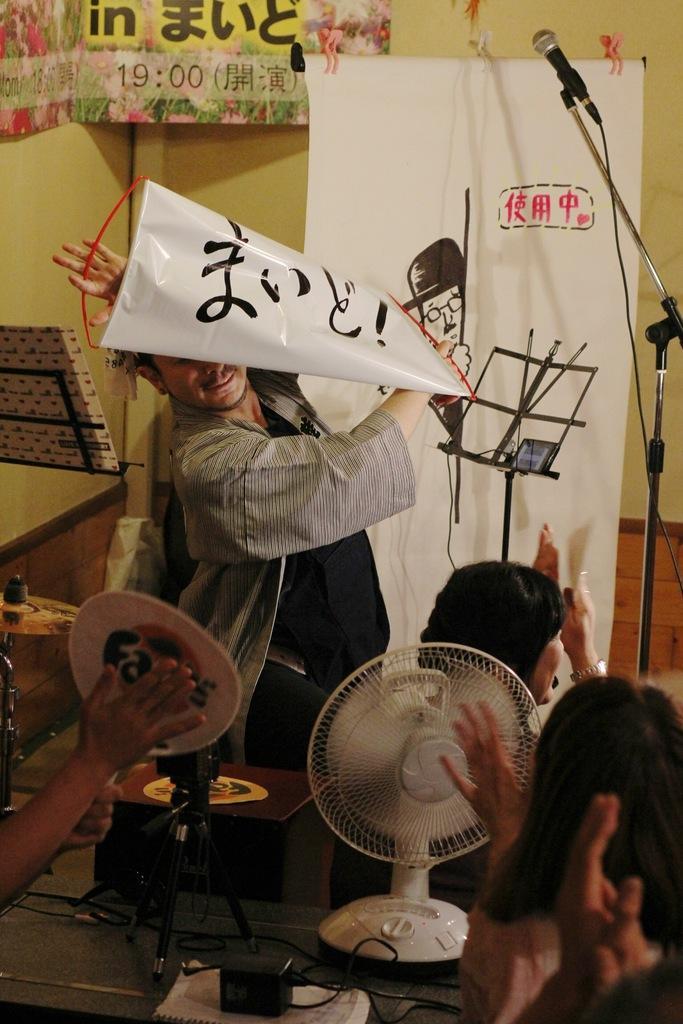Describe this image in one or two sentences. In the picture we can see a man standing and holding some thing in the hand and top of him and beside him we can see some women are sitting and clapping hands and in the background we can see a wall and a white color screen and near it we can see a microphone to the stand. 